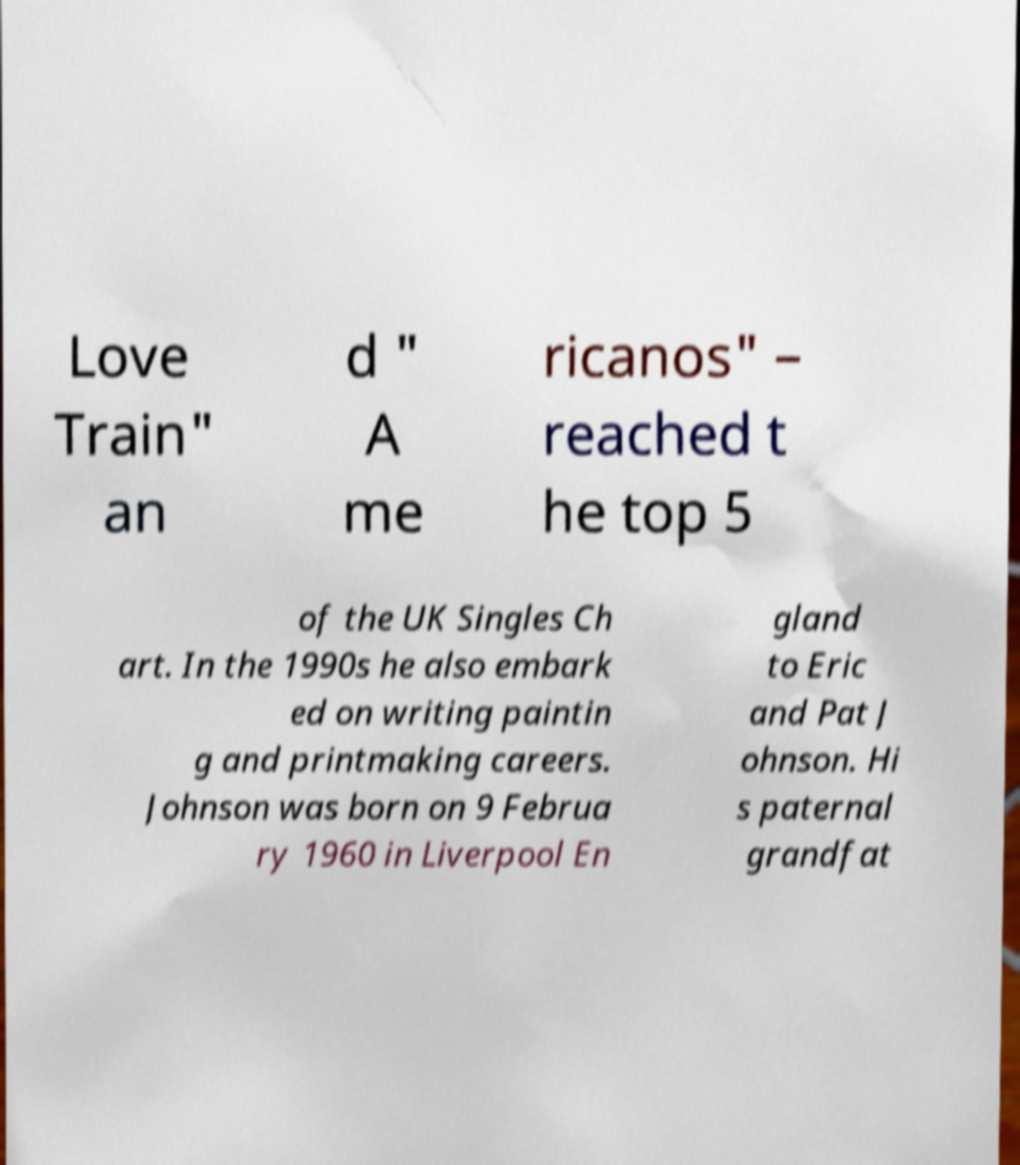What messages or text are displayed in this image? I need them in a readable, typed format. Love Train" an d " A me ricanos" – reached t he top 5 of the UK Singles Ch art. In the 1990s he also embark ed on writing paintin g and printmaking careers. Johnson was born on 9 Februa ry 1960 in Liverpool En gland to Eric and Pat J ohnson. Hi s paternal grandfat 